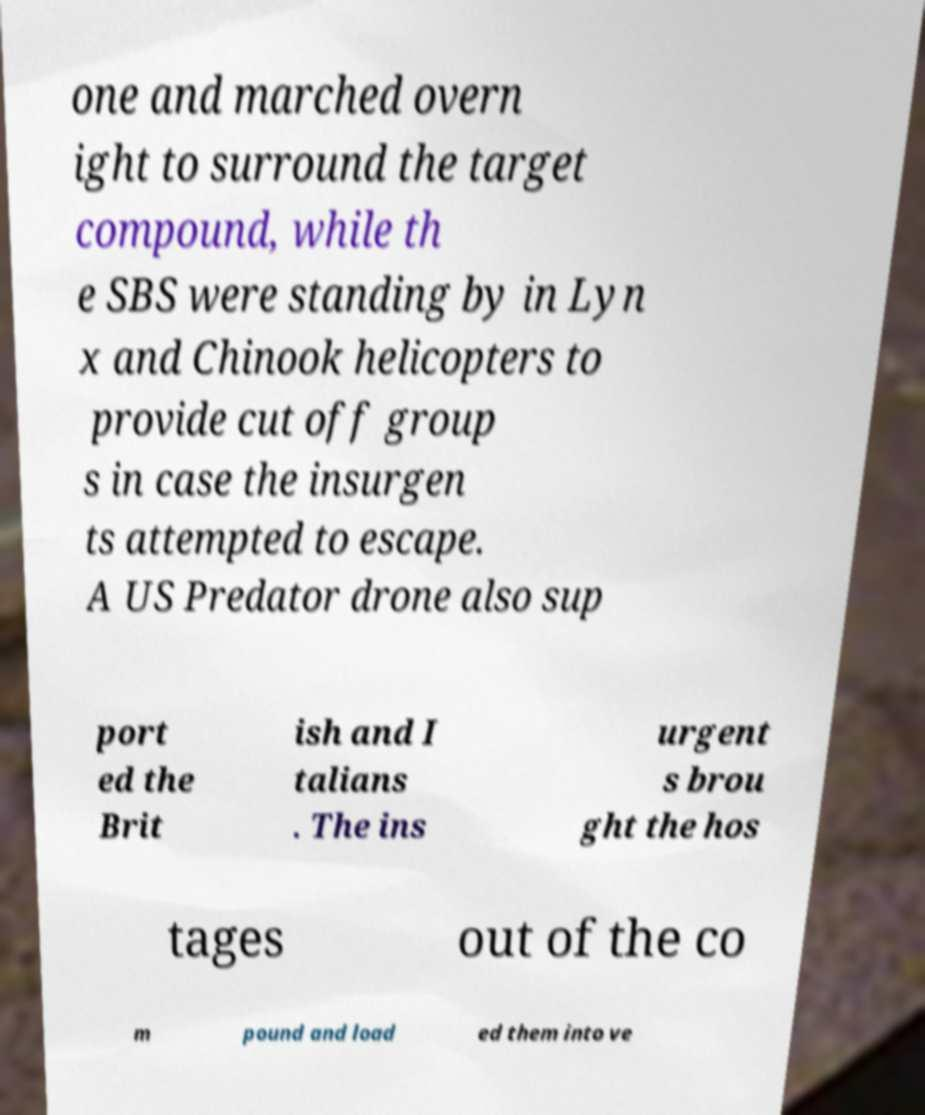Could you assist in decoding the text presented in this image and type it out clearly? one and marched overn ight to surround the target compound, while th e SBS were standing by in Lyn x and Chinook helicopters to provide cut off group s in case the insurgen ts attempted to escape. A US Predator drone also sup port ed the Brit ish and I talians . The ins urgent s brou ght the hos tages out of the co m pound and load ed them into ve 